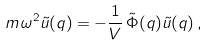Convert formula to latex. <formula><loc_0><loc_0><loc_500><loc_500>m \, \omega ^ { 2 } \tilde { u } ( q ) = - \frac { 1 } { V } \, \tilde { \Phi } ( q ) \tilde { u } ( q ) \, ,</formula> 